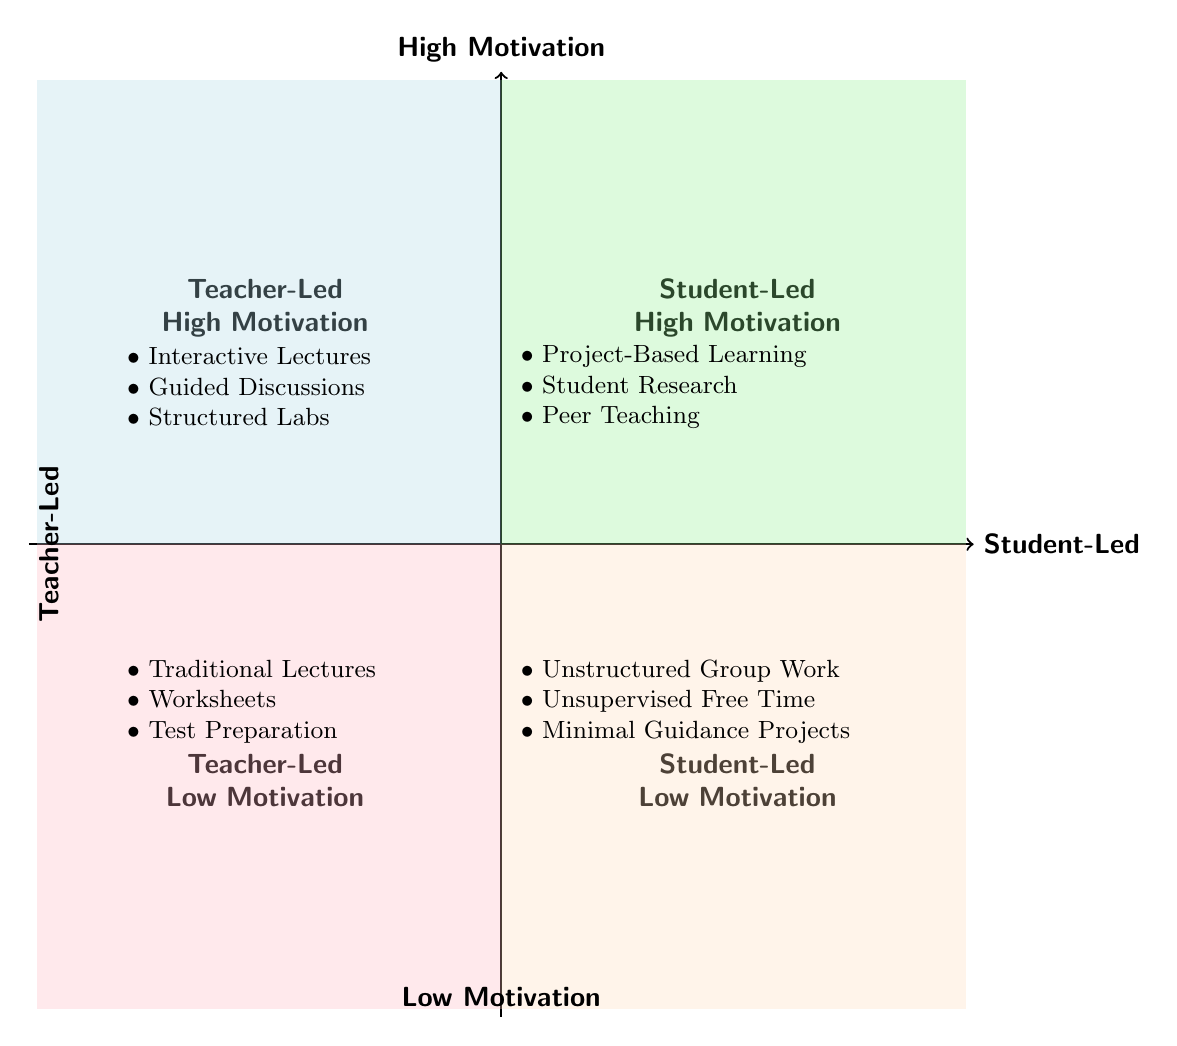What's in Quadrant 1? Quadrant 1 is labeled "Teacher-Led High Motivation" and lists examples like Interactive Lectures, Guided Discussions, and Structured Labs.
Answer: Teacher-Led High Motivation How many examples are listed in Quadrant 3? Quadrant 3 is labeled "Teacher-Led Low Motivation" and has three examples: Traditional Lectures, Worksheets, and Test Preparation.
Answer: 3 What is the key element of Quadrant 2? Quadrant 2, labeled "Student-Led High Motivation," has key elements including student autonomy, collaborative environment, and personalized learning paths. One key element is student autonomy.
Answer: Student autonomy Which quadrant contains "Unstructured Group Work"? "Unstructured Group Work" is an example in Quadrant 4, which is labeled "Student-Led Low Motivation."
Answer: Quadrant 4 What is the focus of Quadrant 3? The focus of Quadrant 3 is on a teacher-centered approach, limited student engagement, and rote memorization as indicated by its definition.
Answer: Teacher-centered approach What contrasts "Project-Based Learning" in the chart? "Project-Based Learning," listed in Quadrant 2 (Student-Led High Motivation), contrasts with the examples in Quadrant 3, which illustrate Teacher-Led Low Motivation activities.
Answer: Teacher-Led Low Motivation Which quadrant has a lack of direction as a key element? Quadrant 4, labeled "Student-Led Low Motivation", has a key element of lack of direction, indicating challenges in motivation.
Answer: Quadrant 4 What is common between Quadrant 1 and Quadrant 2 regarding motivation? Both Quadrant 1 (Teacher-Led High Motivation) and Quadrant 2 (Student-Led High Motivation) focus on activities that promote high motivation among students.
Answer: High Motivation What kind of environment does Quadrant 2 emphasize? Quadrant 2 emphasizes a collaborative environment as one of its key elements to foster student-led activities.
Answer: Collaborative environment 